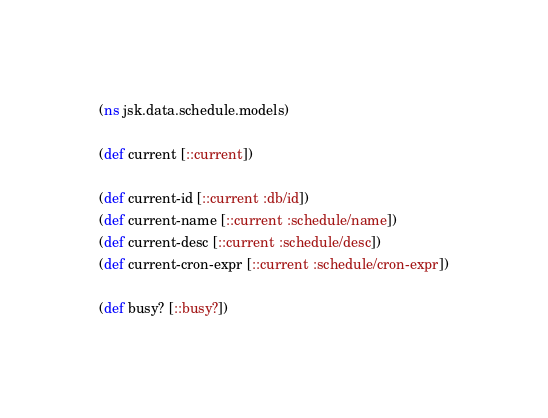Convert code to text. <code><loc_0><loc_0><loc_500><loc_500><_Clojure_>(ns jsk.data.schedule.models)

(def current [::current])

(def current-id [::current :db/id])
(def current-name [::current :schedule/name])
(def current-desc [::current :schedule/desc])
(def current-cron-expr [::current :schedule/cron-expr])

(def busy? [::busy?])
</code> 